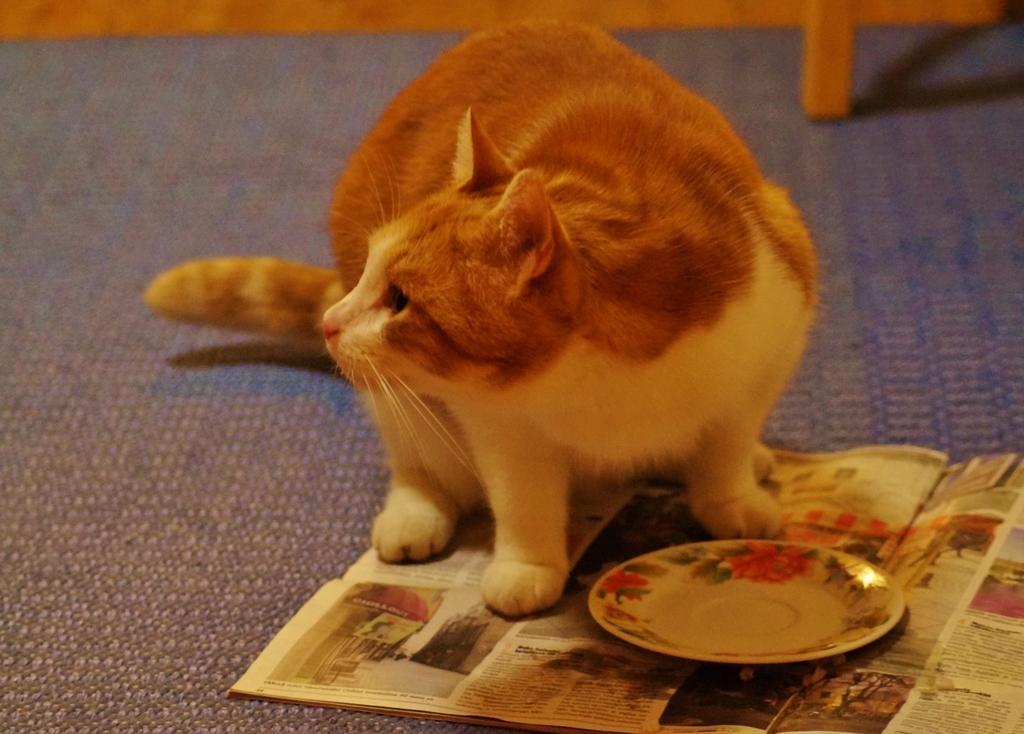Could you give a brief overview of what you see in this image? In the image we can see the cat, plate and newspaper, and here we can see the carpet.  